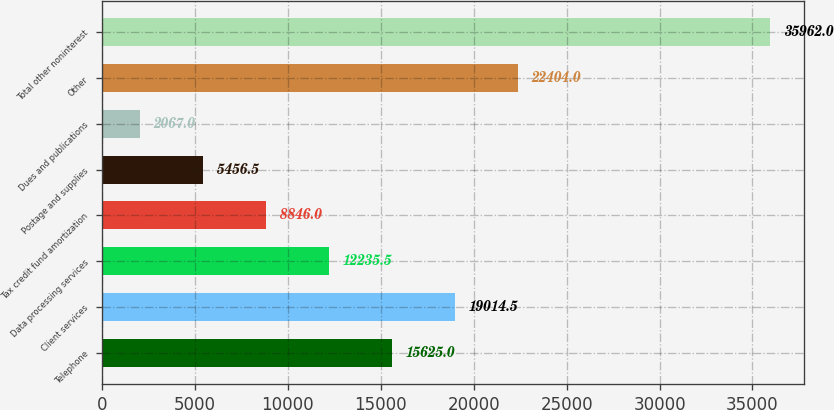Convert chart to OTSL. <chart><loc_0><loc_0><loc_500><loc_500><bar_chart><fcel>Telephone<fcel>Client services<fcel>Data processing services<fcel>Tax credit fund amortization<fcel>Postage and supplies<fcel>Dues and publications<fcel>Other<fcel>Total other noninterest<nl><fcel>15625<fcel>19014.5<fcel>12235.5<fcel>8846<fcel>5456.5<fcel>2067<fcel>22404<fcel>35962<nl></chart> 